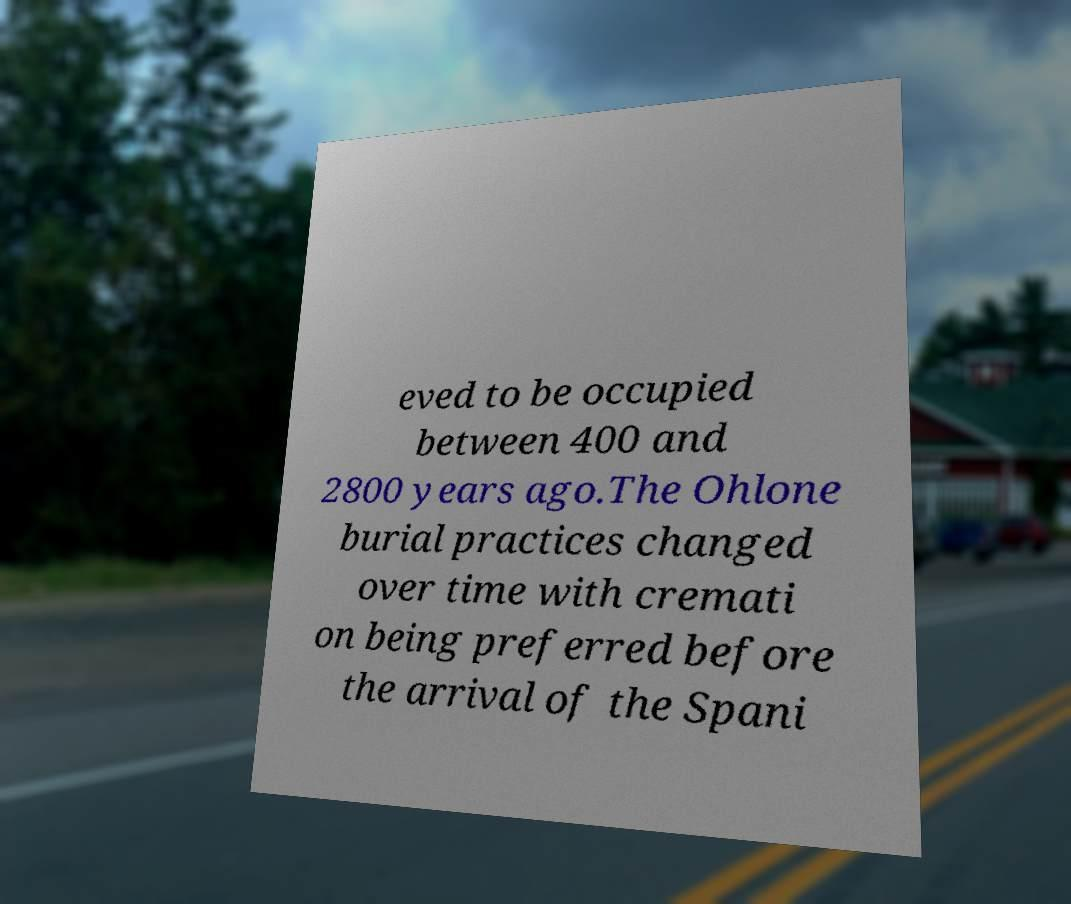Please read and relay the text visible in this image. What does it say? eved to be occupied between 400 and 2800 years ago.The Ohlone burial practices changed over time with cremati on being preferred before the arrival of the Spani 